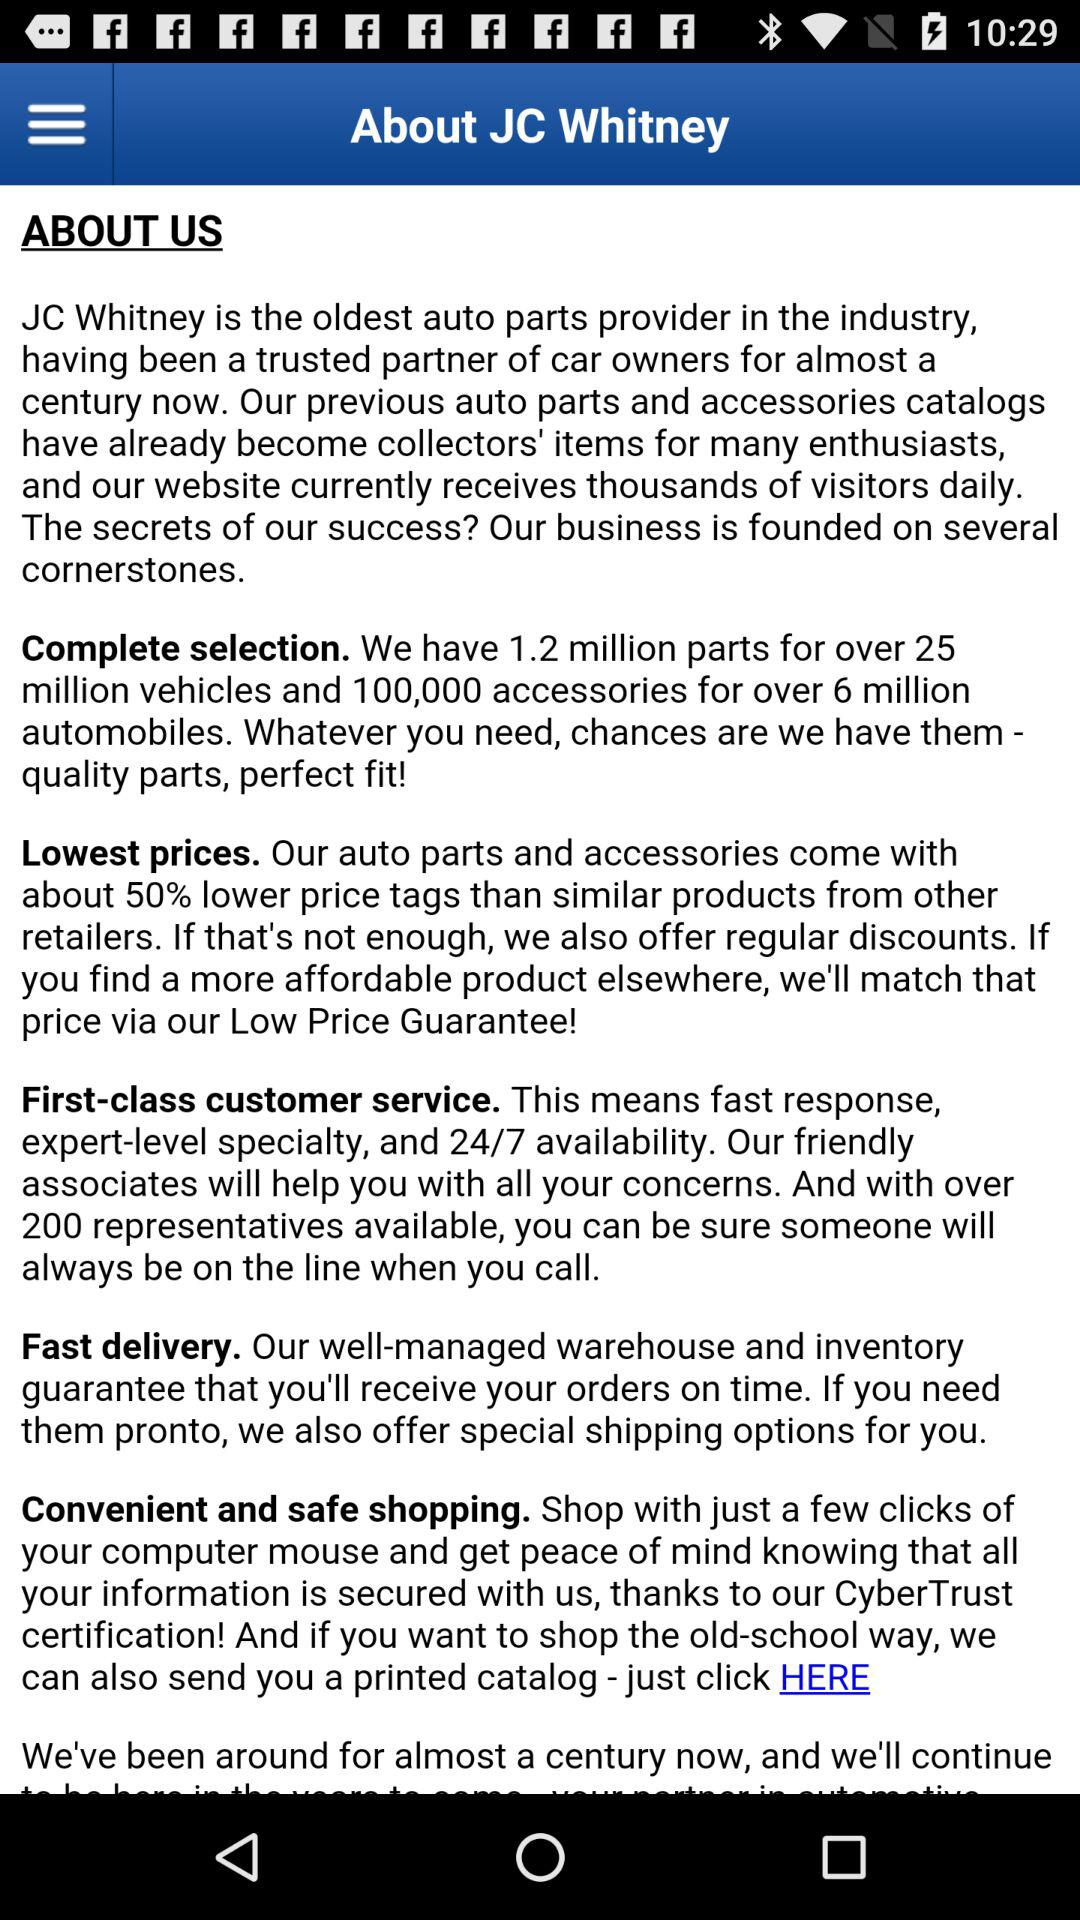Who is the oldest auto parts provider in the industry? The oldest auto parts provider in the industry is JC Whitney. 